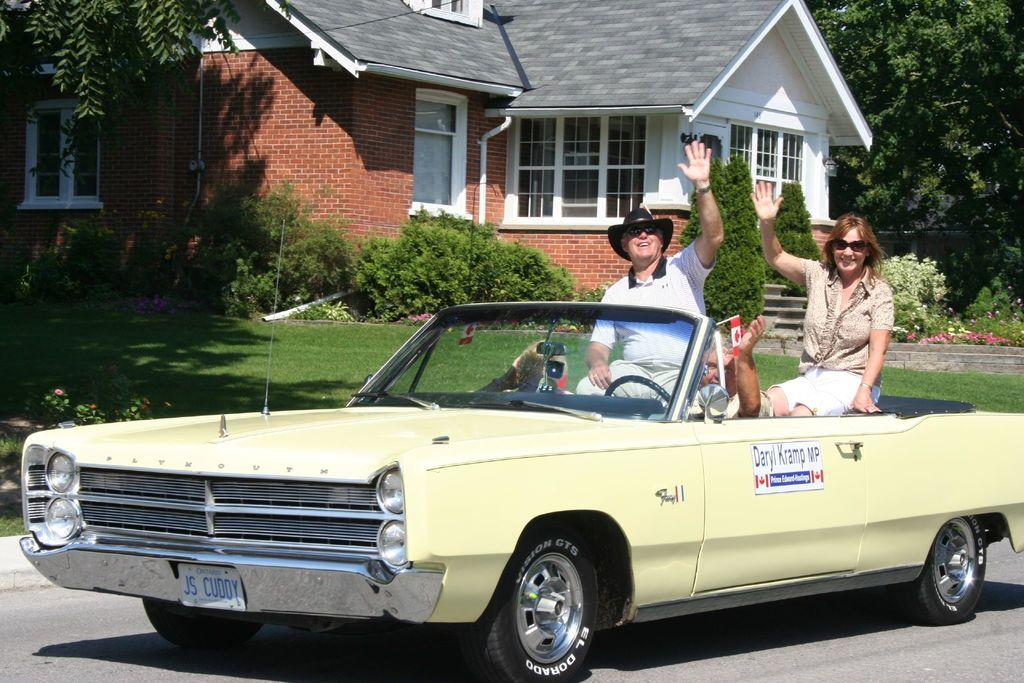What is the main subject of the image? The main subject of the image is a car. Where is the car located in the image? The car is on the road in the image. How many people are inside the car? There are three people sitting inside the car. What can be seen in the background of the image? There is a house and trees in the background of the image. What type of whistle can be heard coming from the car in the image? There is no whistle present in the image, and therefore no sound can be heard. 